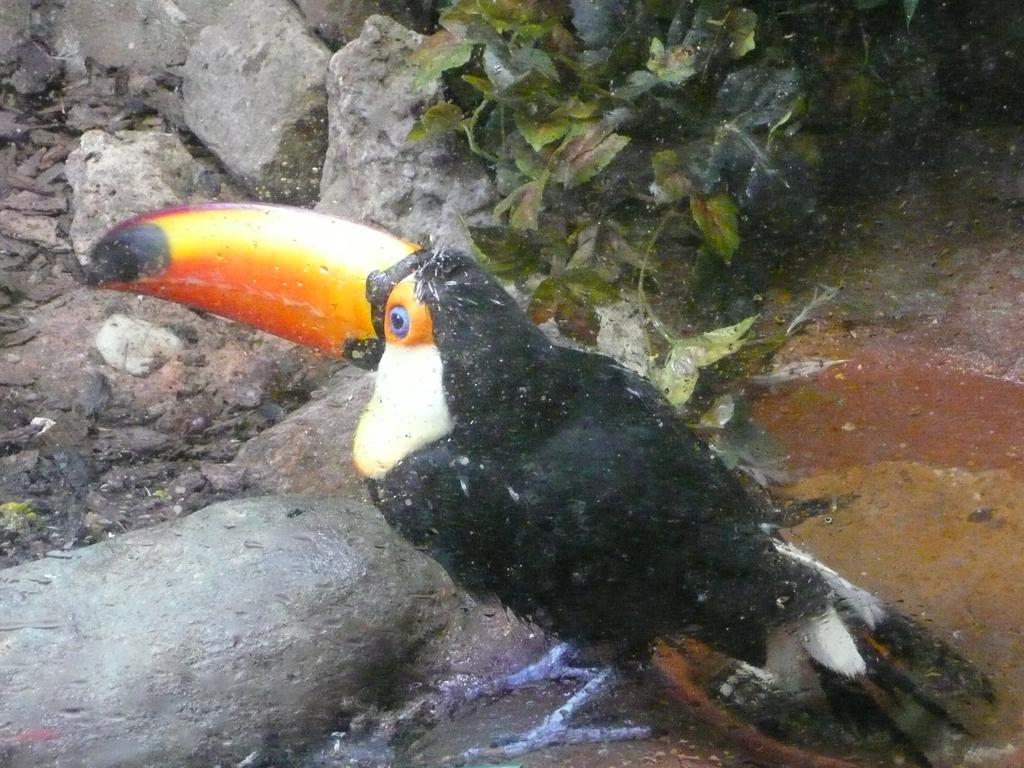What type of animal is on the ground in the image? There is a bird on the ground in the image. What type of natural elements can be seen in the image? There are stones and plants visible in the image. What else is present on the ground in the image? There are objects on the ground in the image. What type of corn is growing on the branch in the image? There is no corn or branch present in the image. What type of school can be seen in the background of the image? There is no school visible in the image. 